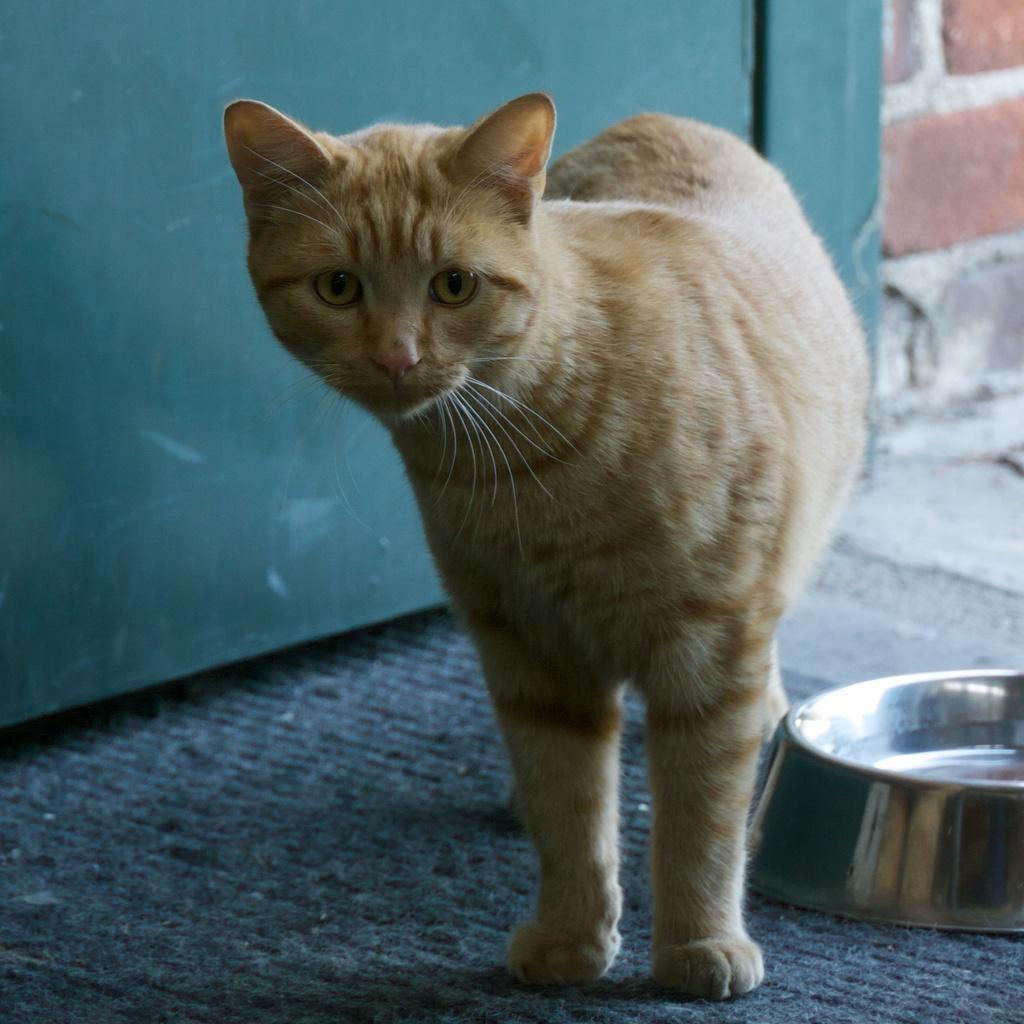Can you describe this image briefly? In this image, we can see a cat. We can see the ground. We can also see a container on the right. In the background, we can see the wall and a green colored object. 